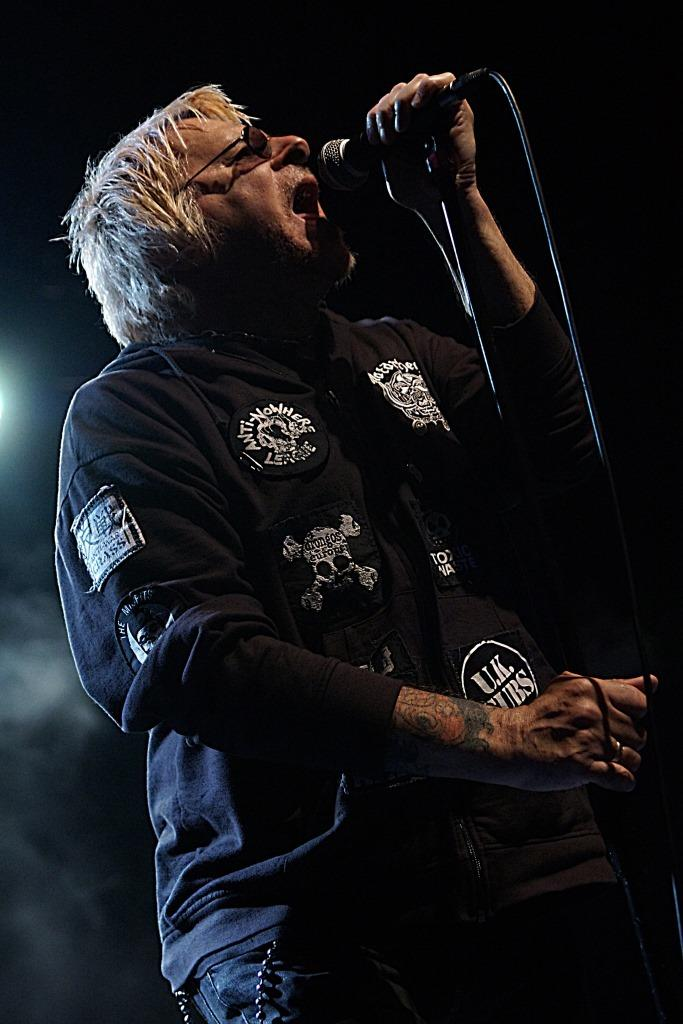Who is the main subject in the image? There is a man in the image. What is the man wearing that is visible in the image? The man is wearing glasses (specs) in the image. What is the man holding in the image? The man is holding a microphone (mic) in the image. What other object related to the microphone can be seen in the image? A mic stand is present in the image. What activity is the man engaged in? The man is singing in the image. What type of art can be seen on the wall behind the man in the image? There is no art visible on the wall behind the man in the image. Can you tell me how many beans are on the man's plate in the image? There is no plate or beans present in the image. 